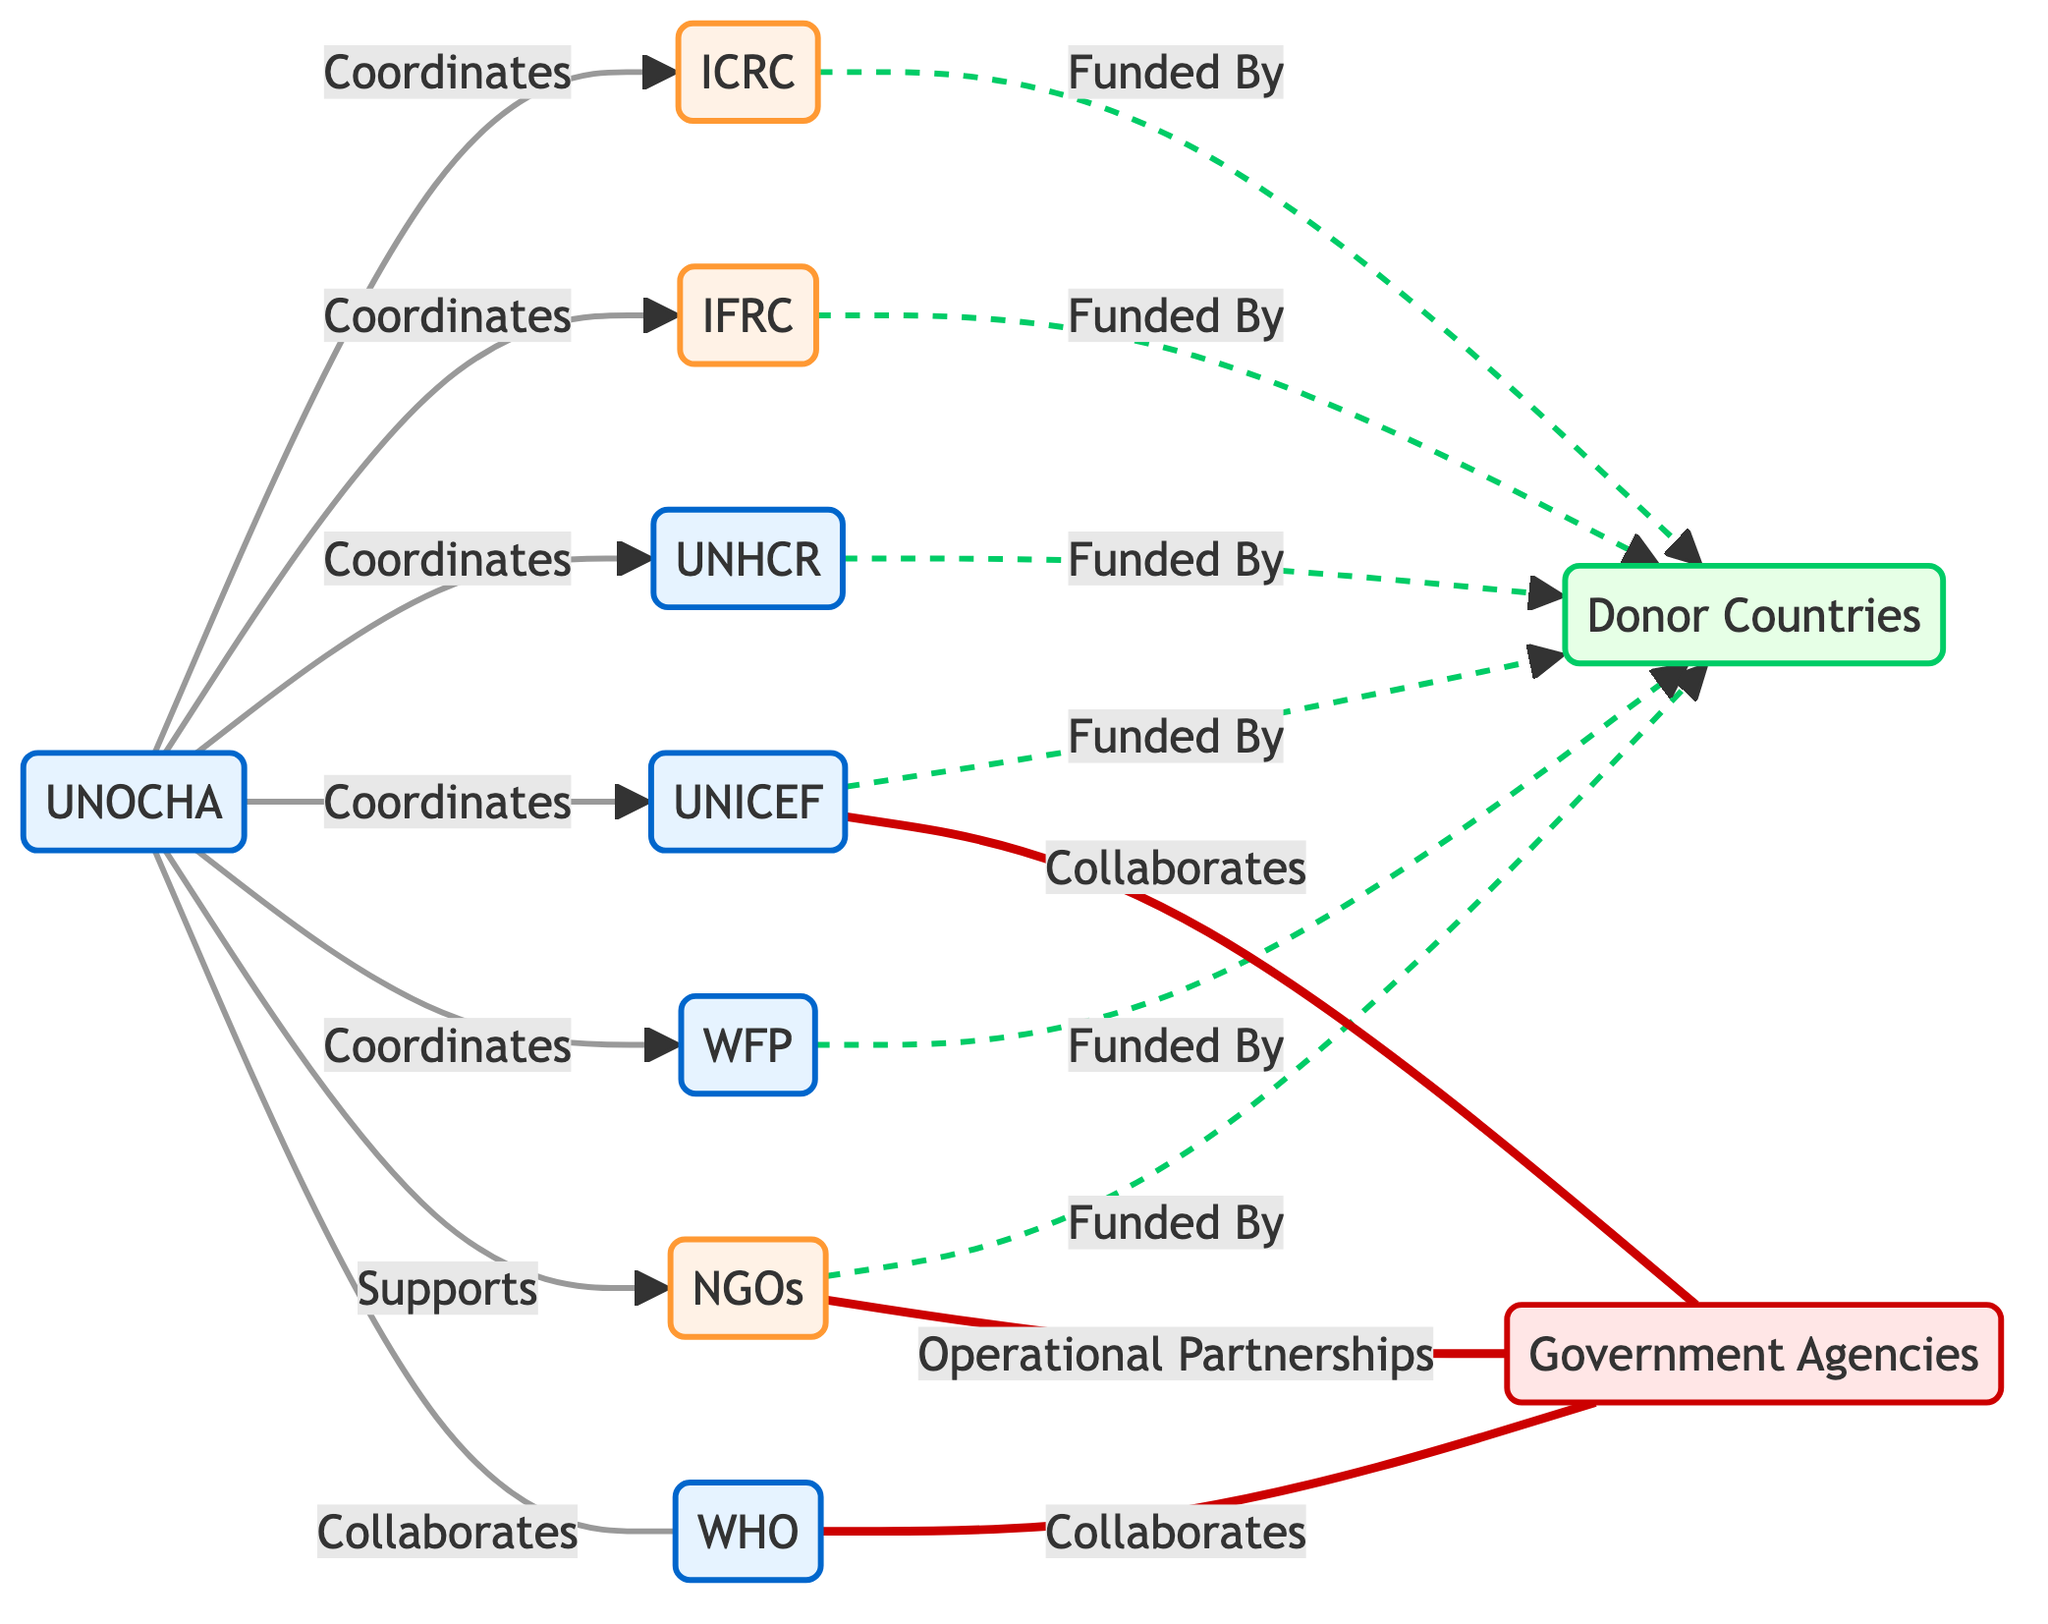What is the total number of international organizations represented in the diagram? The diagram shows the following international organizations: UNOCHA, ICRC, IFRC, UNHCR, UNICEF, WFP, WHO. Counting these, we find there are seven organizations labeled.
Answer: 7 Which organization directly collaborates with WHO? Upon inspecting the connections, the diagram shows that WHO collaborates with both UNOCHA and Government Agencies. To answer the question, we note that both organizations are linked to WHO.
Answer: Government Agencies Who supports the NGOs as indicated in the diagram? The diagram indicates that UNOCHA supports NGOs, shown by the direct connection from UNOCHA to NGOs. Hence, UNOCHA is responsible for supporting them.
Answer: UNOCHA Which entities are funded by Donor Countries? The diagram lists several organizations connected to Donor Countries with labeled connections. These are ICRC, IFRC, UNICEF, WFP, UNHCR, and NGOs. Thus, all these entities receive funding from Donor Countries.
Answer: ICRC, IFRC, UNICEF, WFP, UNHCR, NGOs How many types of organizations are depicted in the diagram? The diagram categorizes organizations into four types: UN, NGO, Donor, and Government Agencies. By identifying these distinct categories, we can conclude the number of types represented.
Answer: 4 What type of relationship exists between NGOs and Government Agencies? The diagram indicates that there is an operational partnership between NGOs and Government Agencies, which is shown by the labeled connection (===) between them. This type defines the nature of their relationship.
Answer: Operational Partnerships Which organizations are coordinated by UNOCHA? The diagram shows multiple organizations connected to UNOCHA. The ones that are coordinated by UNOCHA include ICRC, IFRC, UNHCR, UNICEF, and WFP. This connection showcases the coordinating role of UNOCHA with those entities.
Answer: ICRC, IFRC, UNHCR, UNICEF, WFP What is the nature of the connection between UNICEF and Government Agencies? The diagram indicates a collaboration between UNICEF and Government Agencies, shown by a dashed line connecting these two entities. This implies they work together in some capacity, which is explicitly labeled in their relationship.
Answer: Collaborates Which organization has a direct collaboration with UNOCHA? A review of the diagram reveals that UNOCHA collaborates directly with WHO, as indicated by the line connecting them with a specific label. This clearly specifies their collaborative relationship.
Answer: WHO 